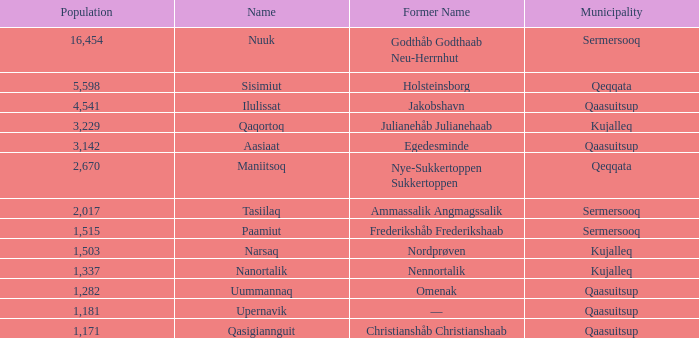What is the population for Rank 11? 1282.0. 